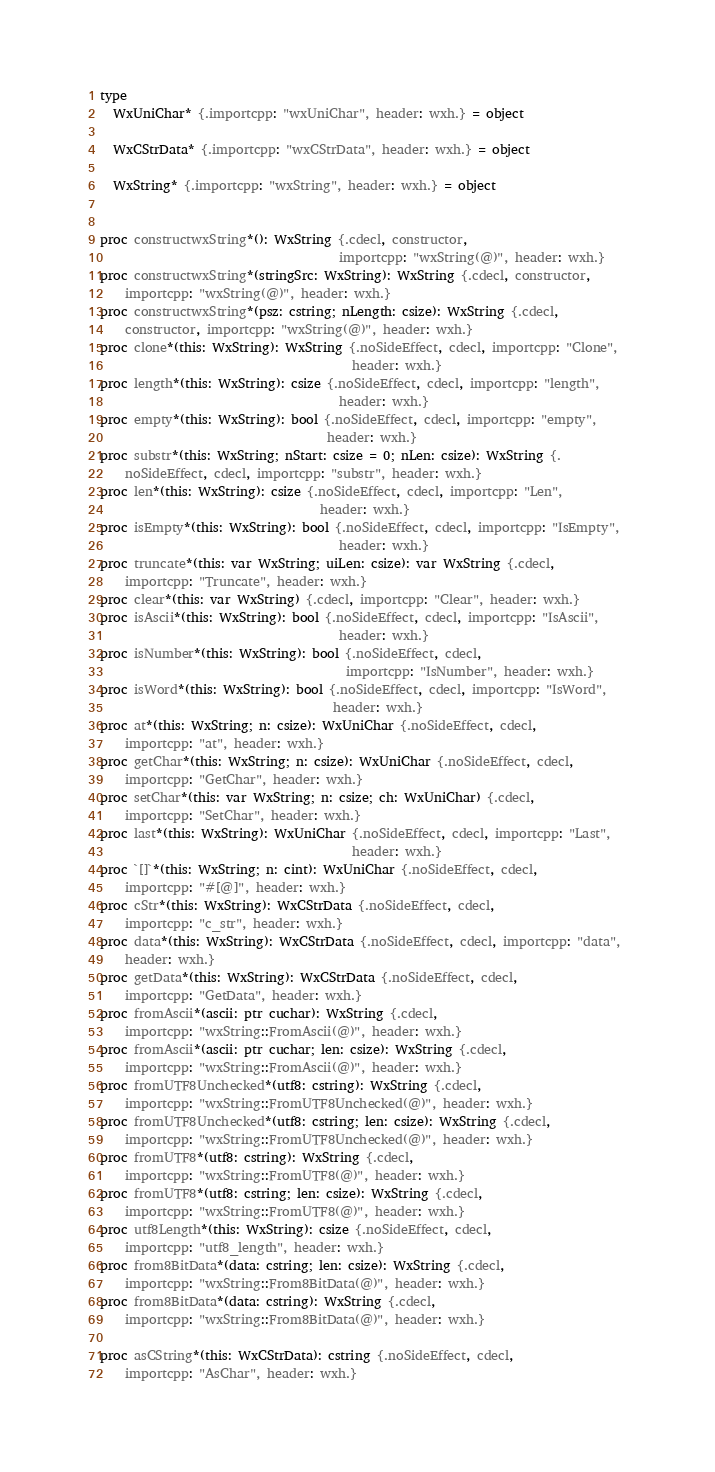Convert code to text. <code><loc_0><loc_0><loc_500><loc_500><_Nim_>

type 
  WxUniChar* {.importcpp: "wxUniChar", header: wxh.} = object 
  
  WxCStrData* {.importcpp: "wxCStrData", header: wxh.} = object 
  
  WxString* {.importcpp: "wxString", header: wxh.} = object 
  

proc constructwxString*(): WxString {.cdecl, constructor, 
                                      importcpp: "wxString(@)", header: wxh.}
proc constructwxString*(stringSrc: WxString): WxString {.cdecl, constructor, 
    importcpp: "wxString(@)", header: wxh.}
proc constructwxString*(psz: cstring; nLength: csize): WxString {.cdecl, 
    constructor, importcpp: "wxString(@)", header: wxh.}
proc clone*(this: WxString): WxString {.noSideEffect, cdecl, importcpp: "Clone", 
                                        header: wxh.}
proc length*(this: WxString): csize {.noSideEffect, cdecl, importcpp: "length", 
                                      header: wxh.}
proc empty*(this: WxString): bool {.noSideEffect, cdecl, importcpp: "empty", 
                                    header: wxh.}
proc substr*(this: WxString; nStart: csize = 0; nLen: csize): WxString {.
    noSideEffect, cdecl, importcpp: "substr", header: wxh.}
proc len*(this: WxString): csize {.noSideEffect, cdecl, importcpp: "Len", 
                                   header: wxh.}
proc isEmpty*(this: WxString): bool {.noSideEffect, cdecl, importcpp: "IsEmpty", 
                                      header: wxh.}
proc truncate*(this: var WxString; uiLen: csize): var WxString {.cdecl, 
    importcpp: "Truncate", header: wxh.}
proc clear*(this: var WxString) {.cdecl, importcpp: "Clear", header: wxh.}
proc isAscii*(this: WxString): bool {.noSideEffect, cdecl, importcpp: "IsAscii", 
                                      header: wxh.}
proc isNumber*(this: WxString): bool {.noSideEffect, cdecl, 
                                       importcpp: "IsNumber", header: wxh.}
proc isWord*(this: WxString): bool {.noSideEffect, cdecl, importcpp: "IsWord", 
                                     header: wxh.}
proc at*(this: WxString; n: csize): WxUniChar {.noSideEffect, cdecl, 
    importcpp: "at", header: wxh.}
proc getChar*(this: WxString; n: csize): WxUniChar {.noSideEffect, cdecl, 
    importcpp: "GetChar", header: wxh.}
proc setChar*(this: var WxString; n: csize; ch: WxUniChar) {.cdecl, 
    importcpp: "SetChar", header: wxh.}
proc last*(this: WxString): WxUniChar {.noSideEffect, cdecl, importcpp: "Last", 
                                        header: wxh.}
proc `[]`*(this: WxString; n: cint): WxUniChar {.noSideEffect, cdecl, 
    importcpp: "#[@]", header: wxh.}
proc cStr*(this: WxString): WxCStrData {.noSideEffect, cdecl, 
    importcpp: "c_str", header: wxh.}
proc data*(this: WxString): WxCStrData {.noSideEffect, cdecl, importcpp: "data", 
    header: wxh.}
proc getData*(this: WxString): WxCStrData {.noSideEffect, cdecl, 
    importcpp: "GetData", header: wxh.}
proc fromAscii*(ascii: ptr cuchar): WxString {.cdecl, 
    importcpp: "wxString::FromAscii(@)", header: wxh.}
proc fromAscii*(ascii: ptr cuchar; len: csize): WxString {.cdecl, 
    importcpp: "wxString::FromAscii(@)", header: wxh.}
proc fromUTF8Unchecked*(utf8: cstring): WxString {.cdecl, 
    importcpp: "wxString::FromUTF8Unchecked(@)", header: wxh.}
proc fromUTF8Unchecked*(utf8: cstring; len: csize): WxString {.cdecl, 
    importcpp: "wxString::FromUTF8Unchecked(@)", header: wxh.}
proc fromUTF8*(utf8: cstring): WxString {.cdecl, 
    importcpp: "wxString::FromUTF8(@)", header: wxh.}
proc fromUTF8*(utf8: cstring; len: csize): WxString {.cdecl, 
    importcpp: "wxString::FromUTF8(@)", header: wxh.}
proc utf8Length*(this: WxString): csize {.noSideEffect, cdecl, 
    importcpp: "utf8_length", header: wxh.}
proc from8BitData*(data: cstring; len: csize): WxString {.cdecl, 
    importcpp: "wxString::From8BitData(@)", header: wxh.}
proc from8BitData*(data: cstring): WxString {.cdecl, 
    importcpp: "wxString::From8BitData(@)", header: wxh.}

proc asCString*(this: WxCStrData): cstring {.noSideEffect, cdecl, 
    importcpp: "AsChar", header: wxh.}</code> 